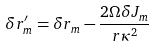<formula> <loc_0><loc_0><loc_500><loc_500>\delta r _ { m } ^ { \prime } = \delta r _ { m } - \frac { 2 \Omega \delta J _ { m } } { r \kappa ^ { 2 } }</formula> 